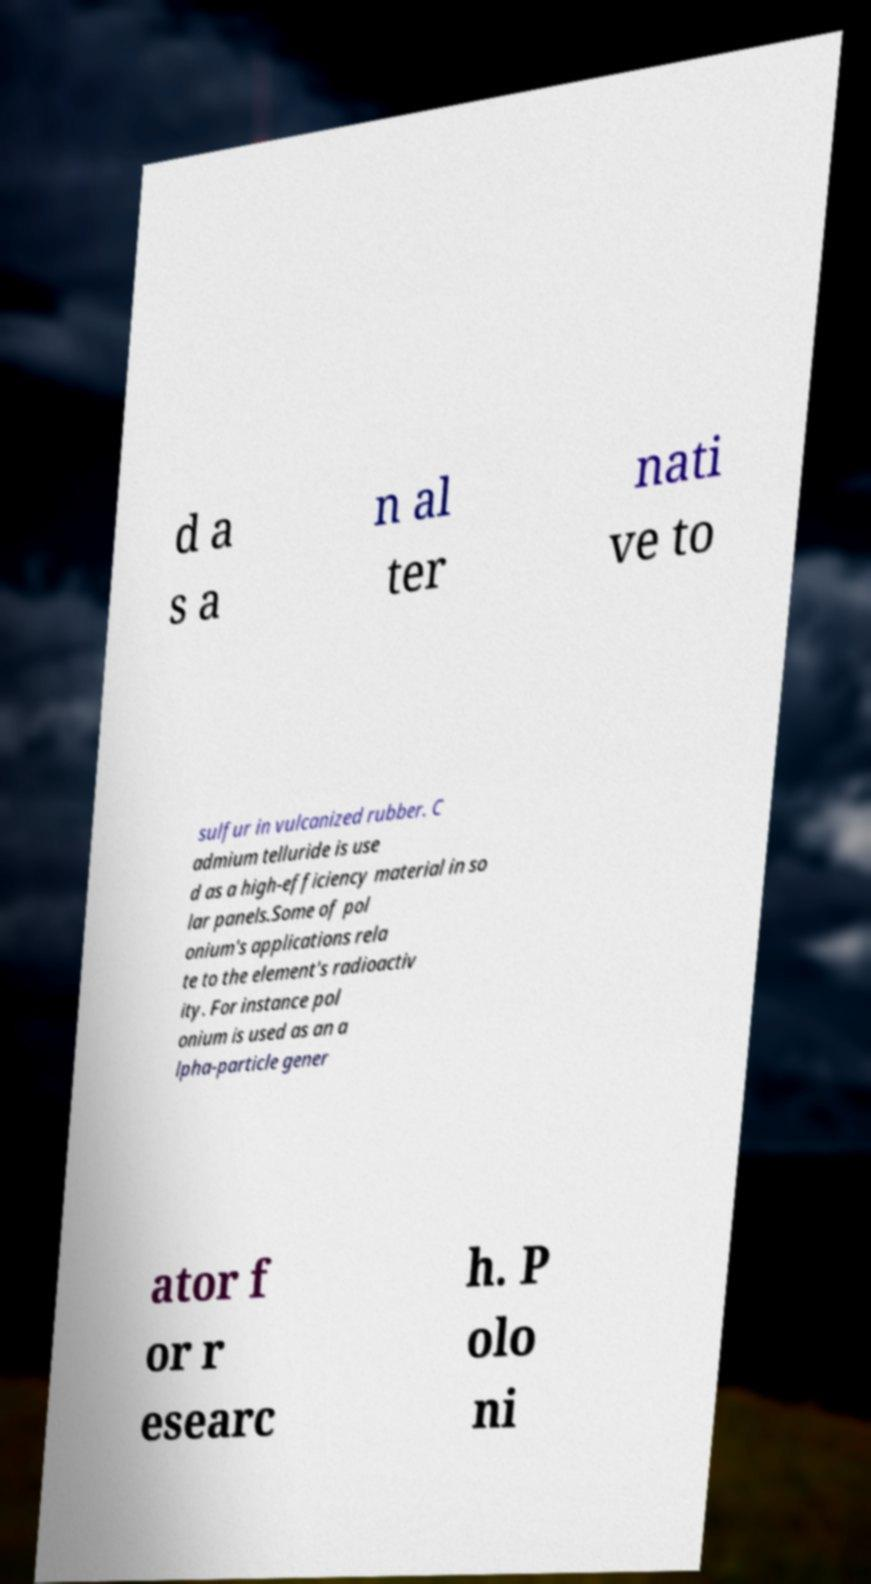Please identify and transcribe the text found in this image. d a s a n al ter nati ve to sulfur in vulcanized rubber. C admium telluride is use d as a high-efficiency material in so lar panels.Some of pol onium's applications rela te to the element's radioactiv ity. For instance pol onium is used as an a lpha-particle gener ator f or r esearc h. P olo ni 